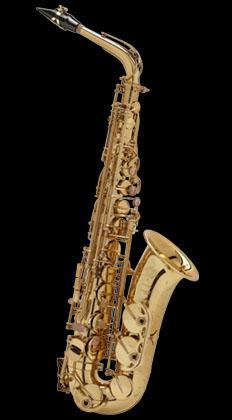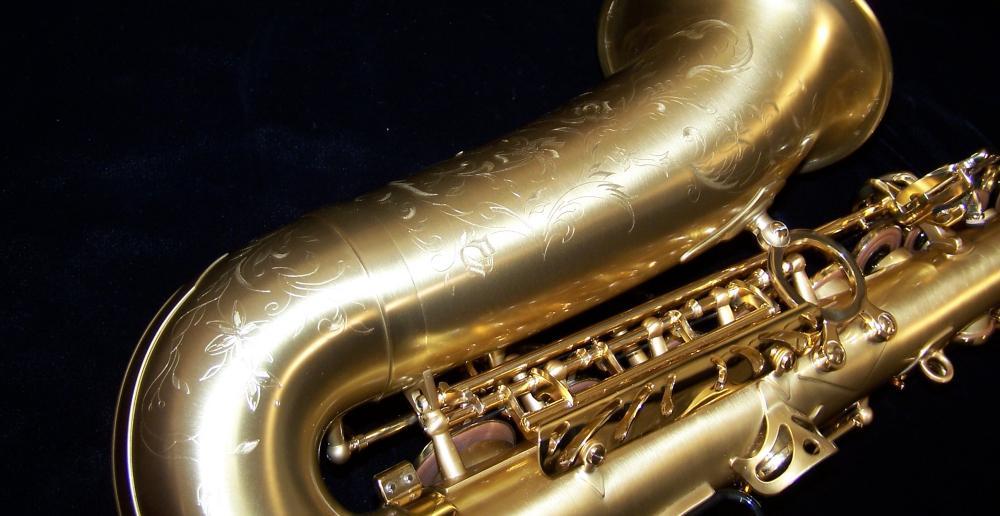The first image is the image on the left, the second image is the image on the right. Examine the images to the left and right. Is the description "One of the saxophones has a floral engraving on the bell." accurate? Answer yes or no. Yes. The first image is the image on the left, the second image is the image on the right. For the images shown, is this caption "The right image shows a saxophone displayed nearly horizontally, with its mouthpiece attached and facing upward." true? Answer yes or no. No. 